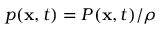Convert formula to latex. <formula><loc_0><loc_0><loc_500><loc_500>p ( x , t ) = P ( x , t ) / \rho</formula> 